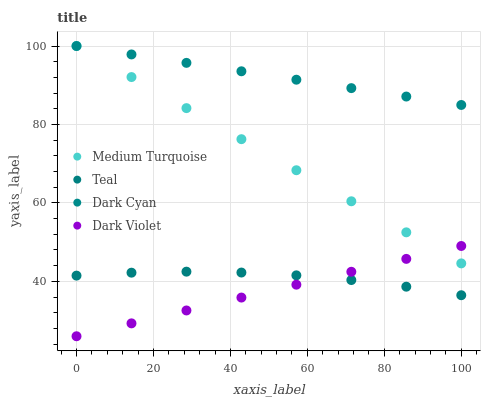Does Dark Violet have the minimum area under the curve?
Answer yes or no. Yes. Does Dark Cyan have the maximum area under the curve?
Answer yes or no. Yes. Does Teal have the minimum area under the curve?
Answer yes or no. No. Does Teal have the maximum area under the curve?
Answer yes or no. No. Is Dark Violet the smoothest?
Answer yes or no. Yes. Is Teal the roughest?
Answer yes or no. Yes. Is Teal the smoothest?
Answer yes or no. No. Is Dark Violet the roughest?
Answer yes or no. No. Does Dark Violet have the lowest value?
Answer yes or no. Yes. Does Teal have the lowest value?
Answer yes or no. No. Does Medium Turquoise have the highest value?
Answer yes or no. Yes. Does Dark Violet have the highest value?
Answer yes or no. No. Is Dark Violet less than Dark Cyan?
Answer yes or no. Yes. Is Dark Cyan greater than Dark Violet?
Answer yes or no. Yes. Does Dark Violet intersect Medium Turquoise?
Answer yes or no. Yes. Is Dark Violet less than Medium Turquoise?
Answer yes or no. No. Is Dark Violet greater than Medium Turquoise?
Answer yes or no. No. Does Dark Violet intersect Dark Cyan?
Answer yes or no. No. 